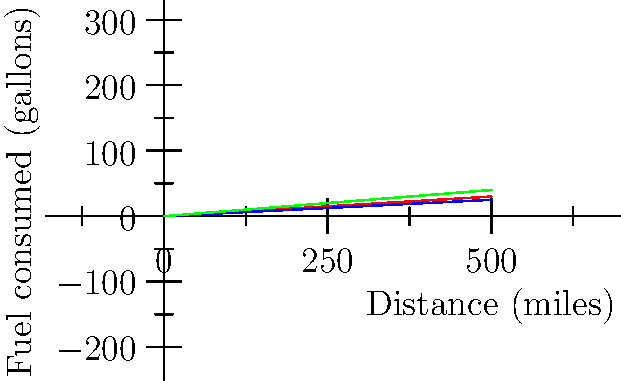During a road trip to visit military museums, you and your fellow veterans decide to compare the fuel efficiency of different vehicles. Using the graph provided, which shows the relationship between distance traveled and fuel consumed for three types of vehicles, calculate the fuel efficiency (in miles per gallon) for the sedan. Round your answer to the nearest whole number. To calculate the fuel efficiency of the sedan, we need to determine how many miles it can travel per gallon of fuel. We can do this by following these steps:

1. Choose two points on the sedan's line (blue line) to calculate the slope.
   Let's use (0,0) and (500,25).

2. Calculate the slope using the formula:
   $$ \text{Slope} = \frac{\text{Change in y}}{\text{Change in x}} = \frac{\text{Fuel consumed}}{\text{Distance traveled}} $$
   $$ \text{Slope} = \frac{25 - 0}{500 - 0} = \frac{25}{500} = 0.05 $$

3. The slope represents gallons per mile. To get miles per gallon (MPG), we need to take the reciprocal:
   $$ \text{MPG} = \frac{1}{\text{Slope}} = \frac{1}{0.05} = 20 $$

4. Rounding to the nearest whole number, we get 20 MPG.
Answer: 20 MPG 